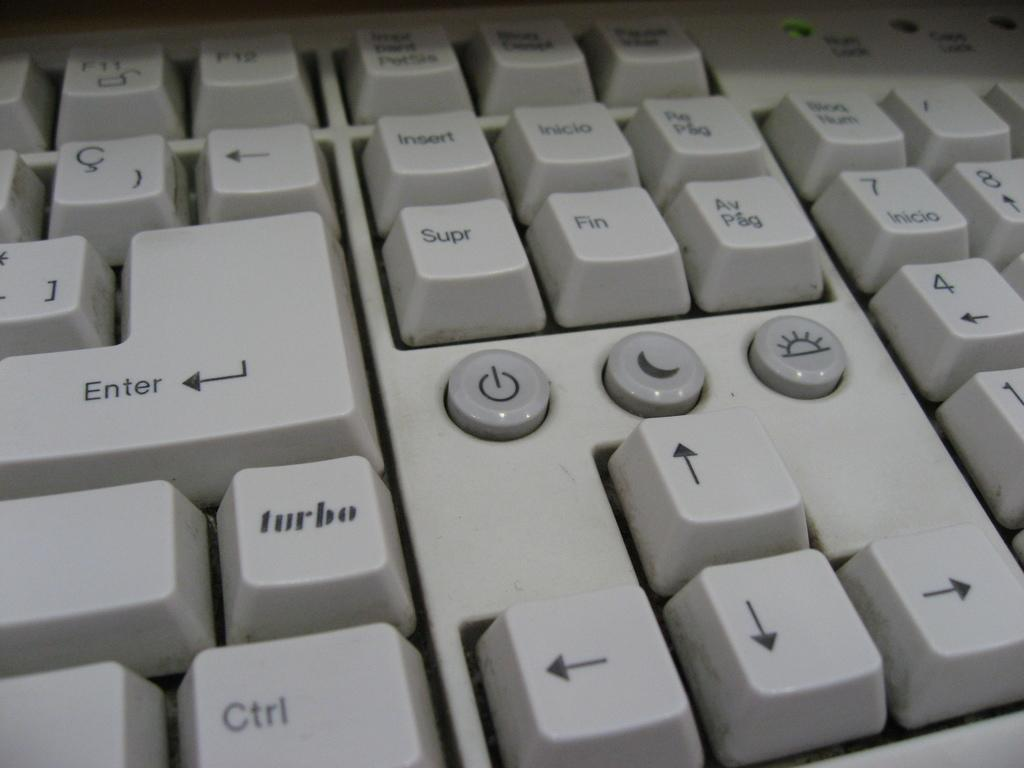<image>
Offer a succinct explanation of the picture presented. A white keyboard with arrows, enter keys and letter keys. 